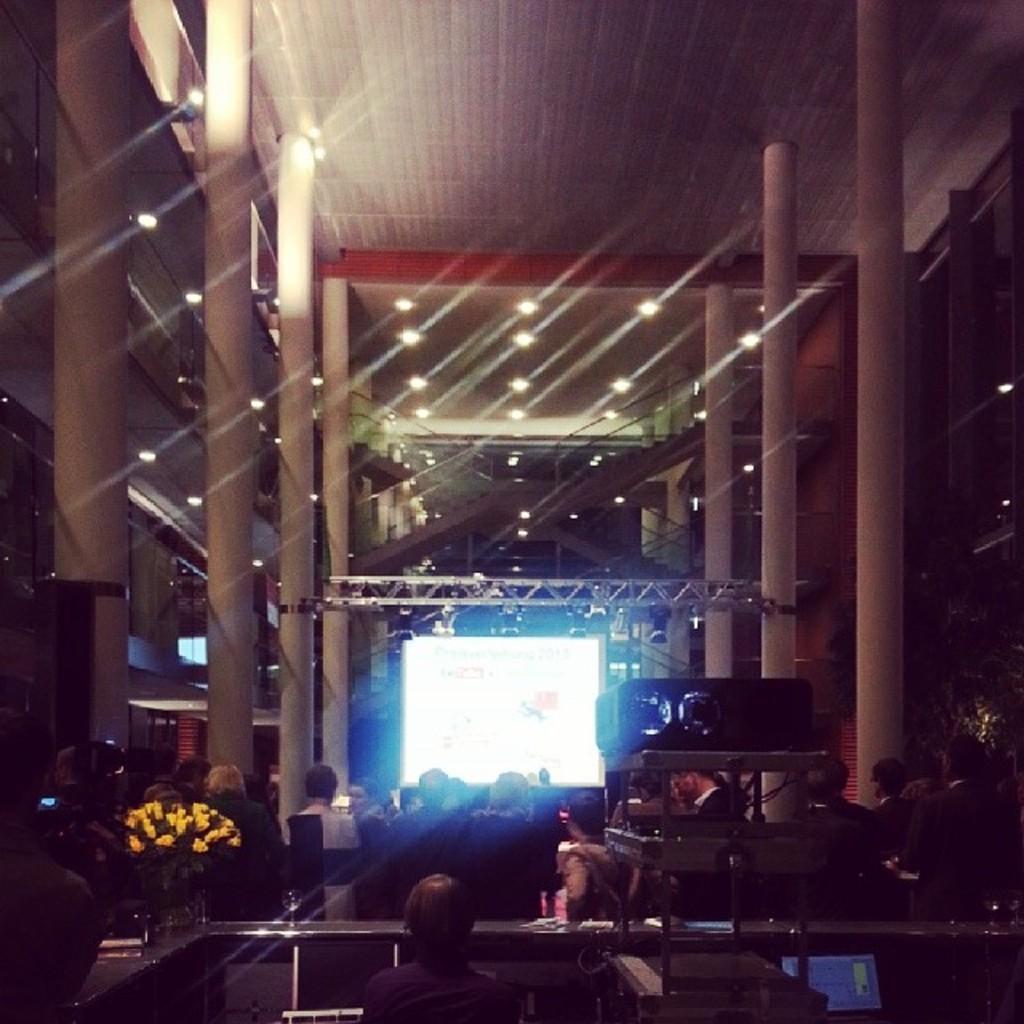Please provide a concise description of this image. We can see people and we can see projector,flowers and some objects on the table and we can see pillars. Background we can see screen and lights. 